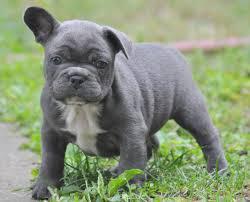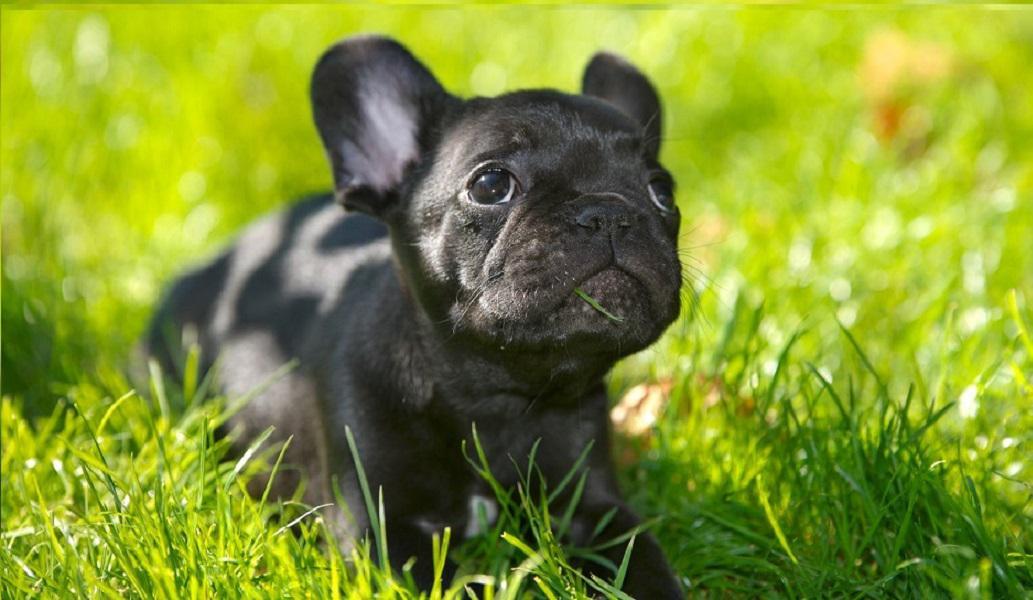The first image is the image on the left, the second image is the image on the right. For the images shown, is this caption "There are three french bulldogs" true? Answer yes or no. No. The first image is the image on the left, the second image is the image on the right. Considering the images on both sides, is "A total of two blackish dogs are shown." valid? Answer yes or no. Yes. 